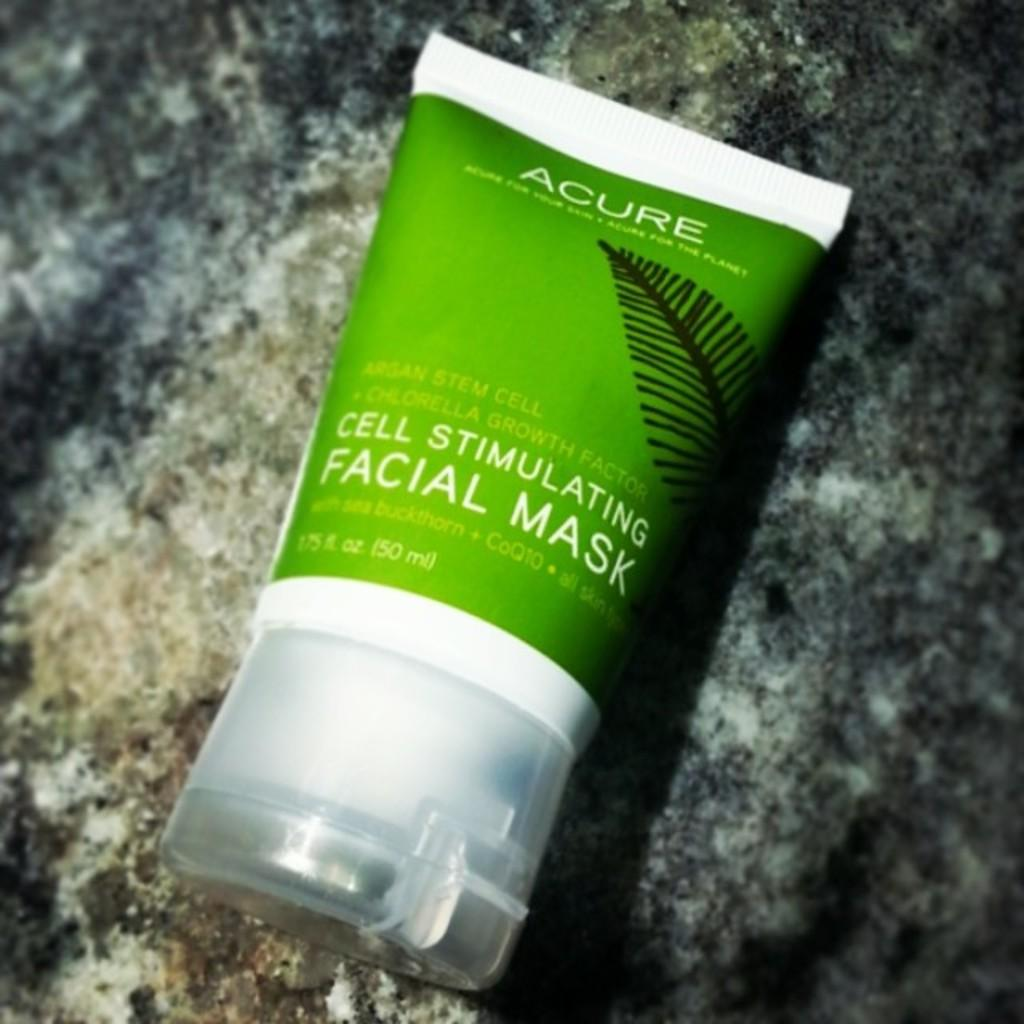<image>
Create a compact narrative representing the image presented. A bottle of Acure Cell Stimulating Facial Mask laying on a granite counter. 